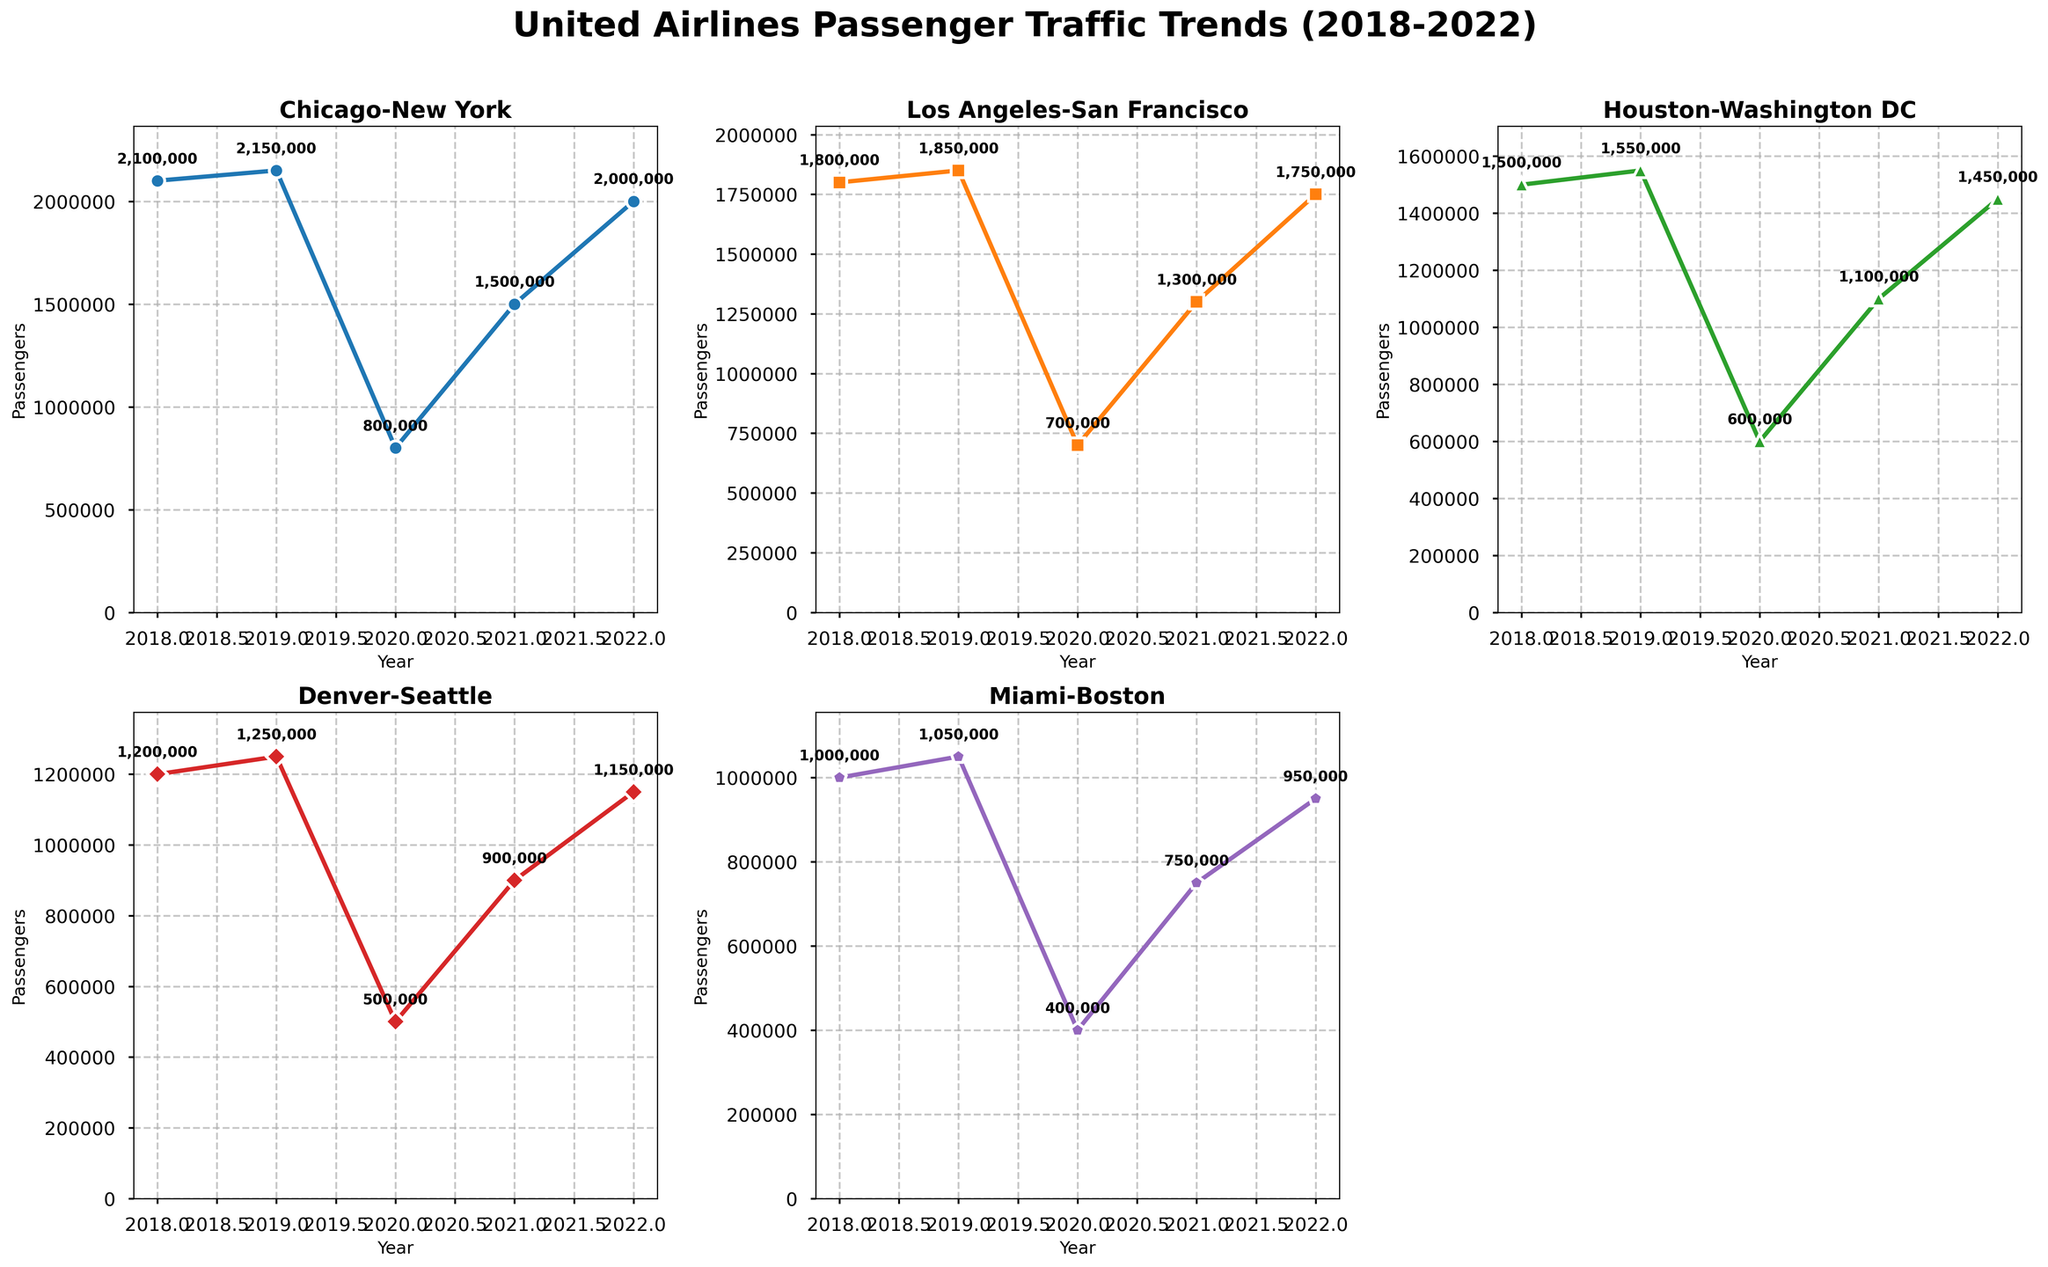what is the title of the figure? The title of the figure is usually placed at the top, here it reads "United Airlines Passenger Traffic Trends (2018-2022)."
Answer: United Airlines Passenger Traffic Trends (2018-2022) What is the color used for the line representing the Chicago-New York route? The Chicago-New York route's line is colored using a blue-like shade, as visible in the figure.
Answer: Blue In which year did the Miami-Boston route have the lowest number of passengers? By observing the Miami-Boston route line, the lowest point on the line appears in the year 2020.
Answer: 2020 By how much did the number of passengers for Houston-Washington DC increase from 2020 to 2021? In 2020, the number of passengers was 600,000, and in 2021 it was 1,100,000. The increase is calculated as 1,100,000 - 600,000 = 500,000.
Answer: 500,000 Which route saw the highest number of passengers in 2022? Looking at the end points for all lines in 2022, the Chicago-New York route reached up to 2,000,000, the highest among them.
Answer: Chicago-New York By what percentage did the number of passengers for the Denver-Seattle route change from 2019 to 2020? In 2019, the number of passengers was 1,250,000 and in 2020 it was 500,000. The percentage change is calculated as [(500,000 - 1,250,000) / 1,250,000] * 100 = -60%.
Answer: -60% How many routes had more than 1,000,000 passengers in both 2021 and 2022? Checking each subplot for counts above 1,000,000 in both years: Chicago-New York, Los Angeles-San Francisco, and Houston-Washington DC have such values for both years.
Answer: 3 Which route experienced the least fluctuation in passenger numbers between 2018 and 2022? Observing the range and variance of the lines: the Miami-Boston route exhibits more stable patterns, indicating the least fluctuation.
Answer: Miami-Boston What visual marker is used for the Denver-Seattle route? The Denver-Seattle route uses a triangular marker at each data point.
Answer: Triangle 